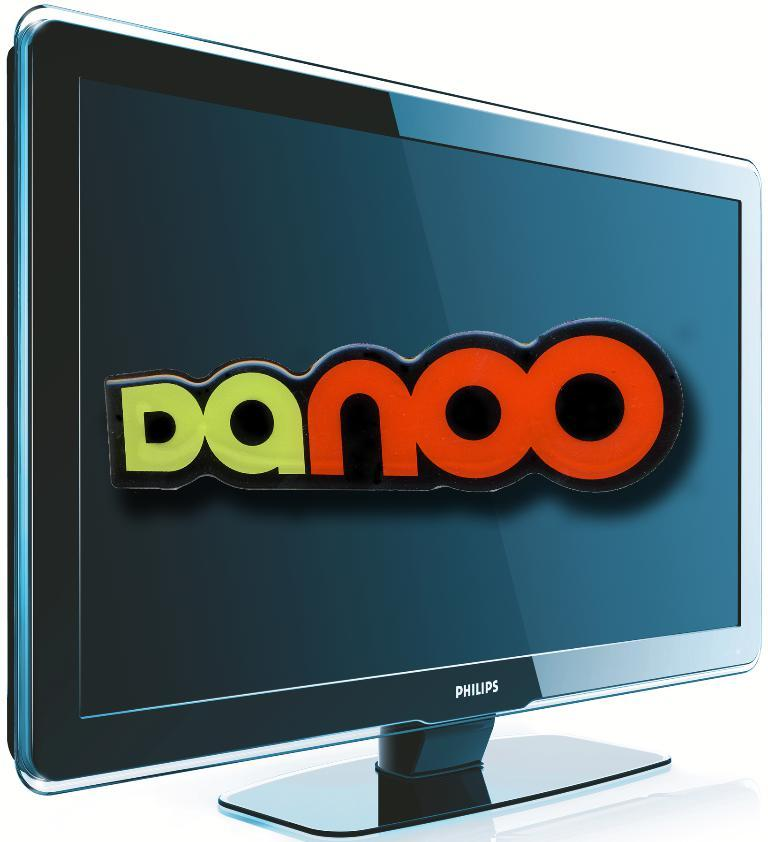<image>
Present a compact description of the photo's key features. Danoo in green and red text on the screen on a Philips monitor. 